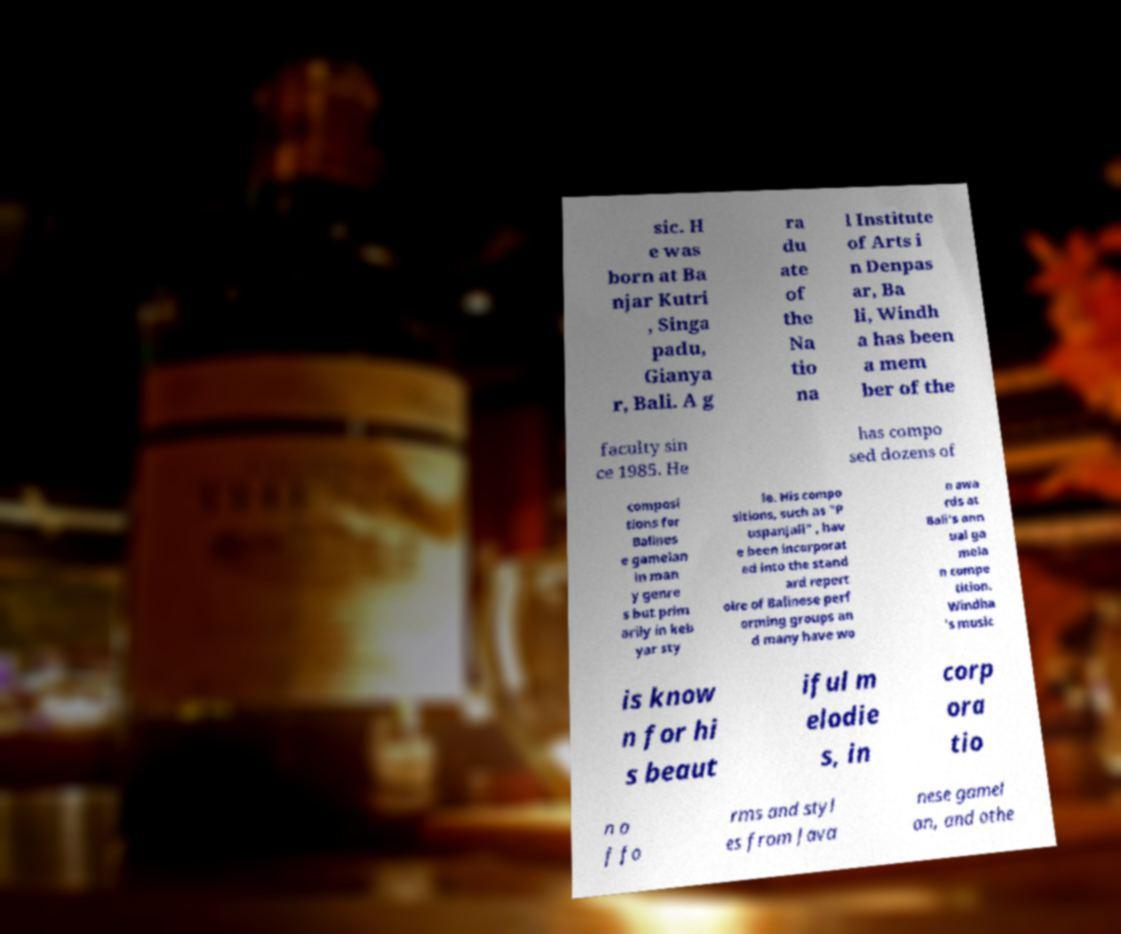Can you read and provide the text displayed in the image?This photo seems to have some interesting text. Can you extract and type it out for me? sic. H e was born at Ba njar Kutri , Singa padu, Gianya r, Bali. A g ra du ate of the Na tio na l Institute of Arts i n Denpas ar, Ba li, Windh a has been a mem ber of the faculty sin ce 1985. He has compo sed dozens of composi tions for Balines e gamelan in man y genre s but prim arily in keb yar sty le. His compo sitions, such as "P uspanjali" , hav e been incorporat ed into the stand ard repert oire of Balinese perf orming groups an d many have wo n awa rds at Bali's ann ual ga mela n compe tition. Windha 's music is know n for hi s beaut iful m elodie s, in corp ora tio n o f fo rms and styl es from Java nese gamel an, and othe 